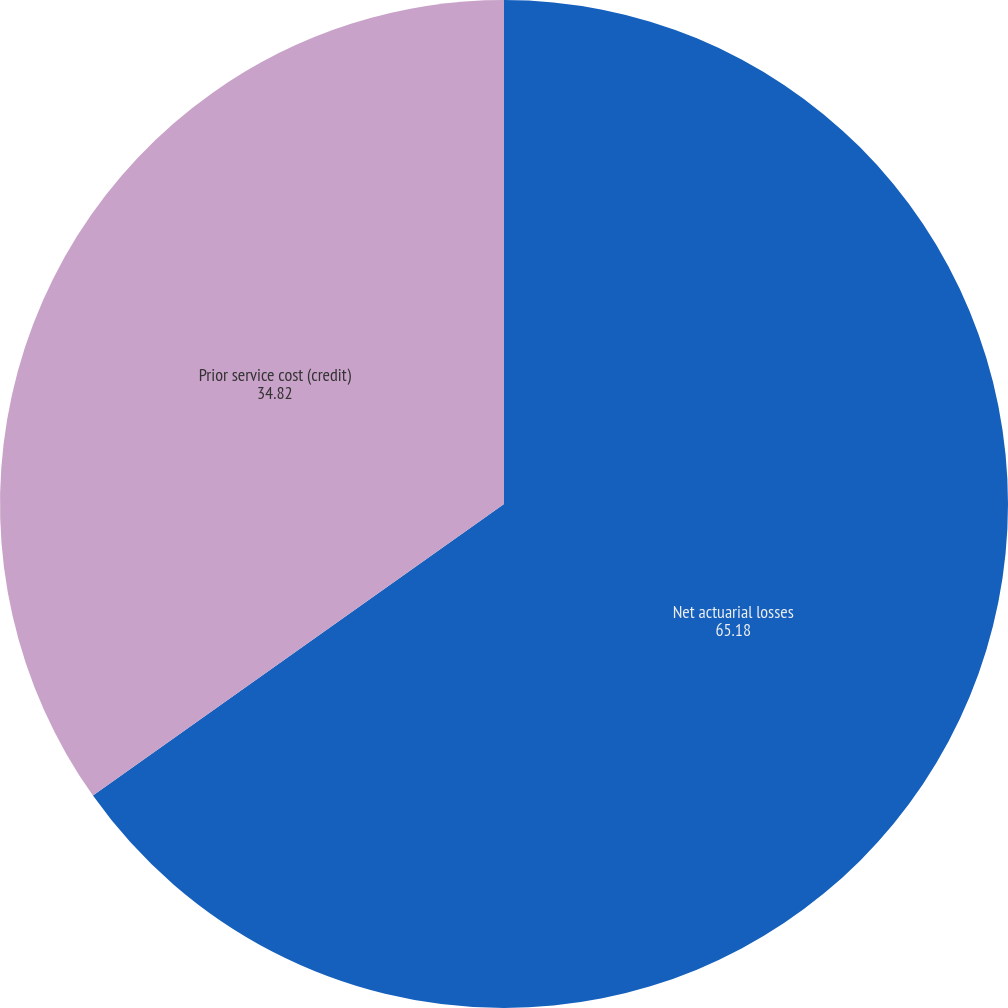Convert chart. <chart><loc_0><loc_0><loc_500><loc_500><pie_chart><fcel>Net actuarial losses<fcel>Prior service cost (credit)<nl><fcel>65.18%<fcel>34.82%<nl></chart> 